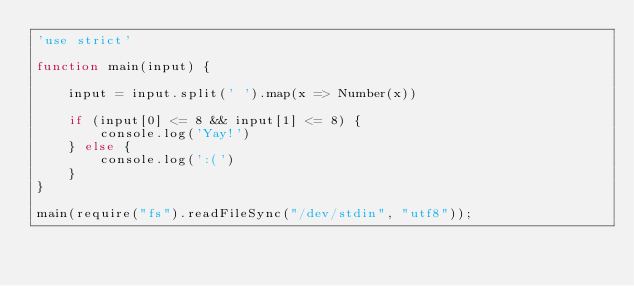<code> <loc_0><loc_0><loc_500><loc_500><_JavaScript_>'use strict'

function main(input) {

    input = input.split(' ').map(x => Number(x))

    if (input[0] <= 8 && input[1] <= 8) {
        console.log('Yay!')
    } else {
        console.log(':(')
    }
}

main(require("fs").readFileSync("/dev/stdin", "utf8"));
</code> 